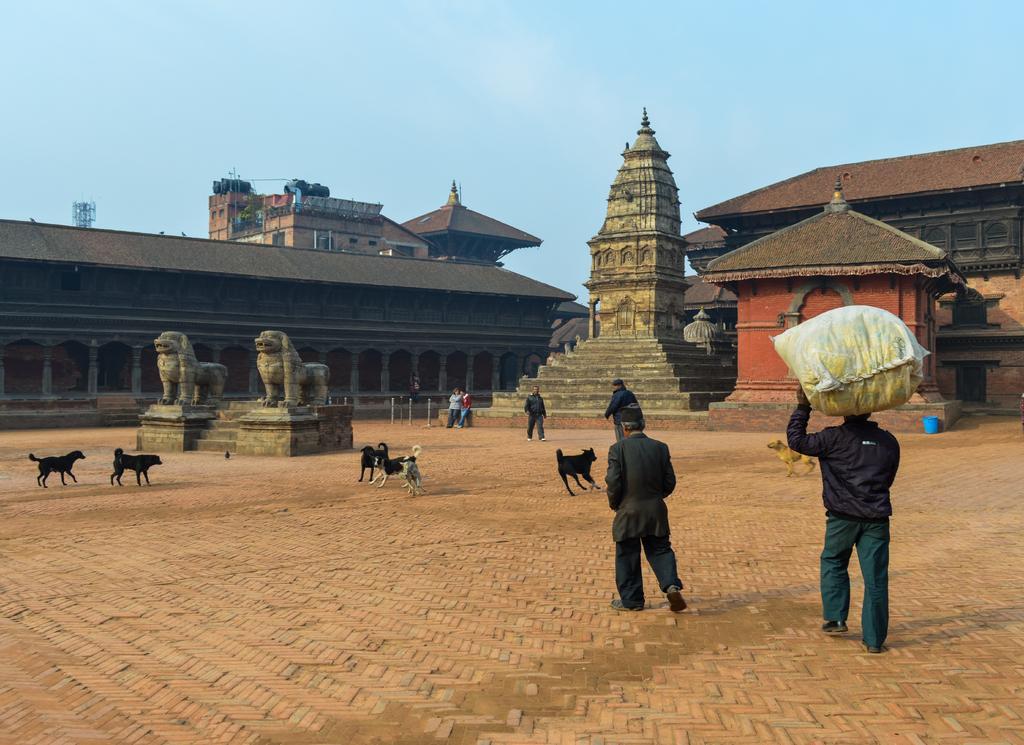Could you give a brief overview of what you see in this image? In this image we can see people and dogs on the pavement. In the background, we can see buildings and statues. At the top of the image, we can see the sky. On the right side of the image, we can see a sack on the head of a person and a blue color object is present. 